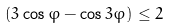Convert formula to latex. <formula><loc_0><loc_0><loc_500><loc_500>( 3 \cos \varphi - \cos 3 \varphi ) \leq 2</formula> 